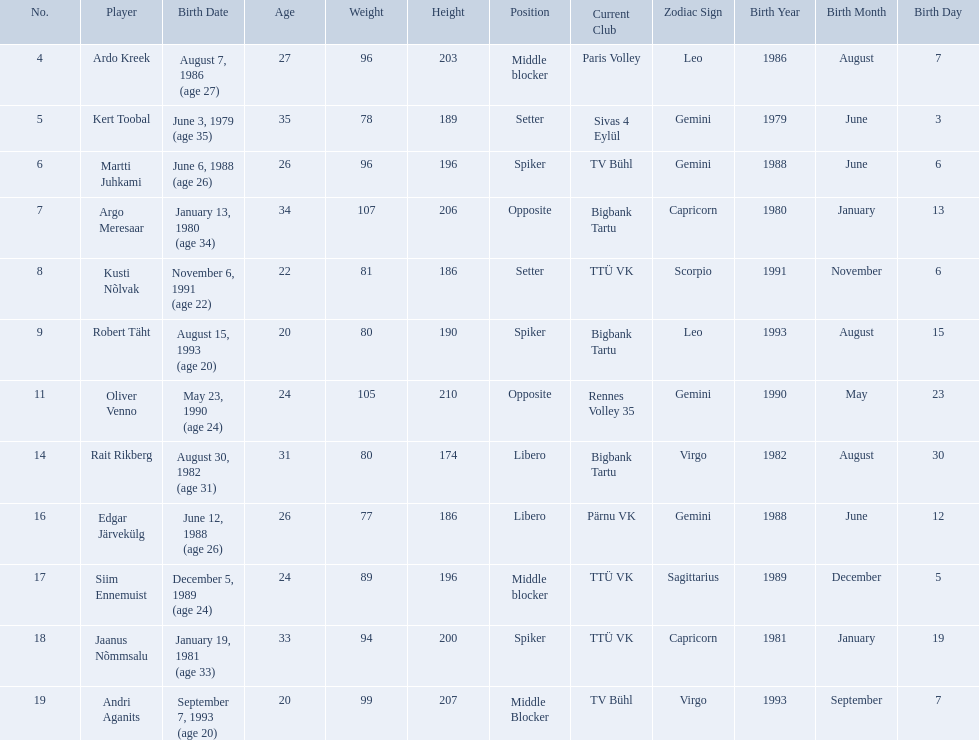Who are the players of the estonian men's national volleyball team? Ardo Kreek, Kert Toobal, Martti Juhkami, Argo Meresaar, Kusti Nõlvak, Robert Täht, Oliver Venno, Rait Rikberg, Edgar Järvekülg, Siim Ennemuist, Jaanus Nõmmsalu, Andri Aganits. Of these, which have a height over 200? Ardo Kreek, Argo Meresaar, Oliver Venno, Andri Aganits. Of the remaining, who is the tallest? Oliver Venno. 